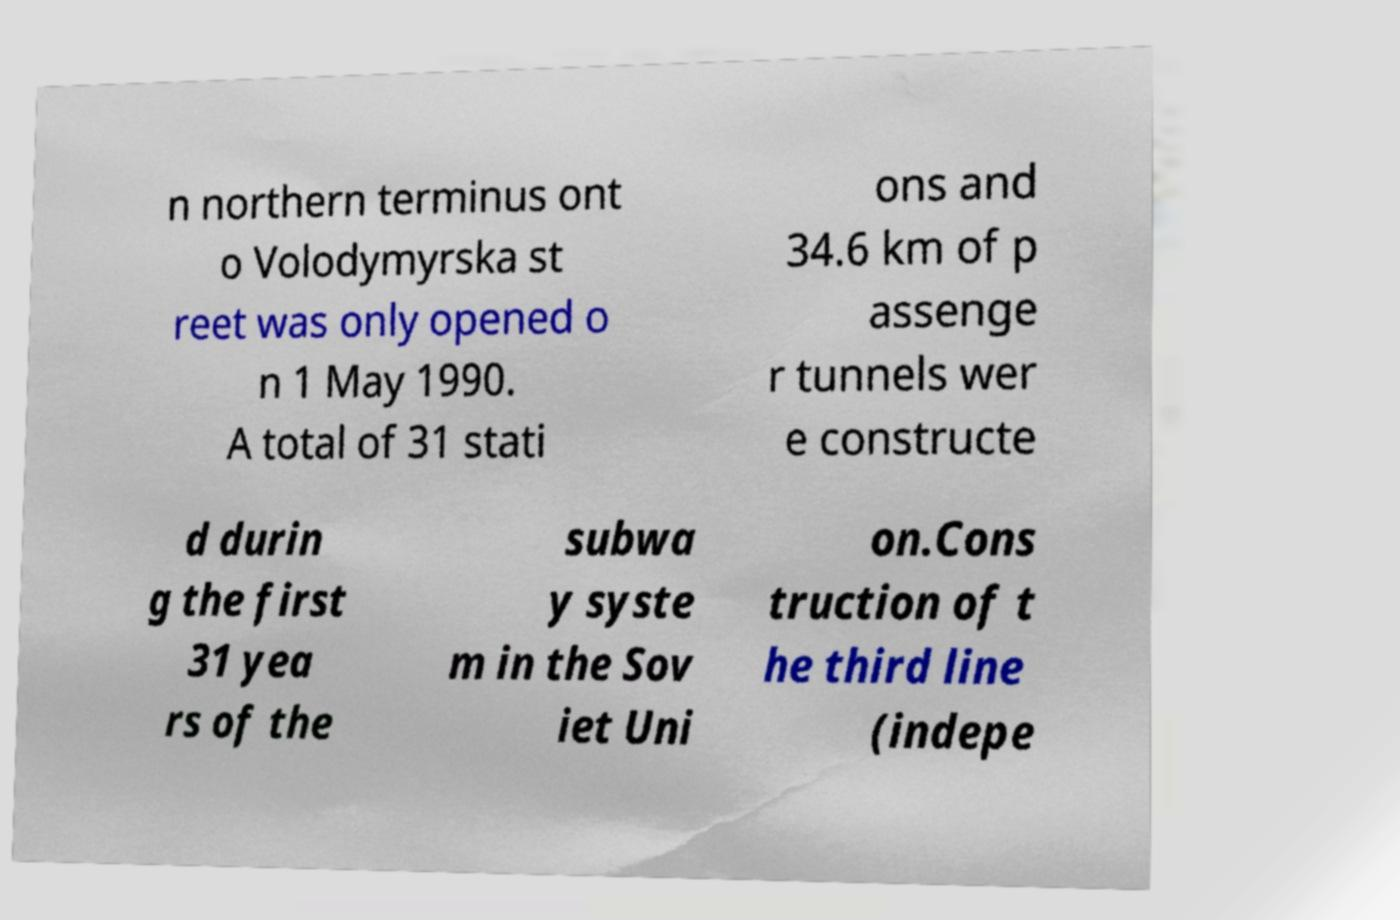There's text embedded in this image that I need extracted. Can you transcribe it verbatim? n northern terminus ont o Volodymyrska st reet was only opened o n 1 May 1990. A total of 31 stati ons and 34.6 km of p assenge r tunnels wer e constructe d durin g the first 31 yea rs of the subwa y syste m in the Sov iet Uni on.Cons truction of t he third line (indepe 